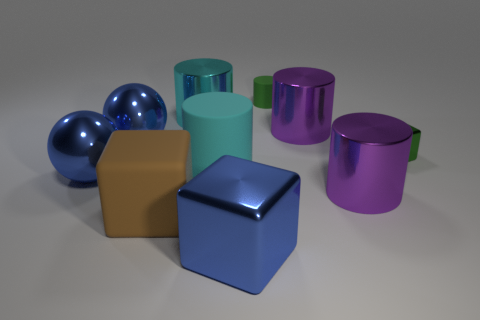Subtract 1 cylinders. How many cylinders are left? 4 Subtract all green cylinders. How many cylinders are left? 4 Subtract all green cylinders. How many cylinders are left? 4 Subtract all blue cylinders. Subtract all green spheres. How many cylinders are left? 5 Subtract all cubes. How many objects are left? 7 Subtract 2 purple cylinders. How many objects are left? 8 Subtract all big purple metal cylinders. Subtract all big blue balls. How many objects are left? 6 Add 1 large blue blocks. How many large blue blocks are left? 2 Add 3 large cubes. How many large cubes exist? 5 